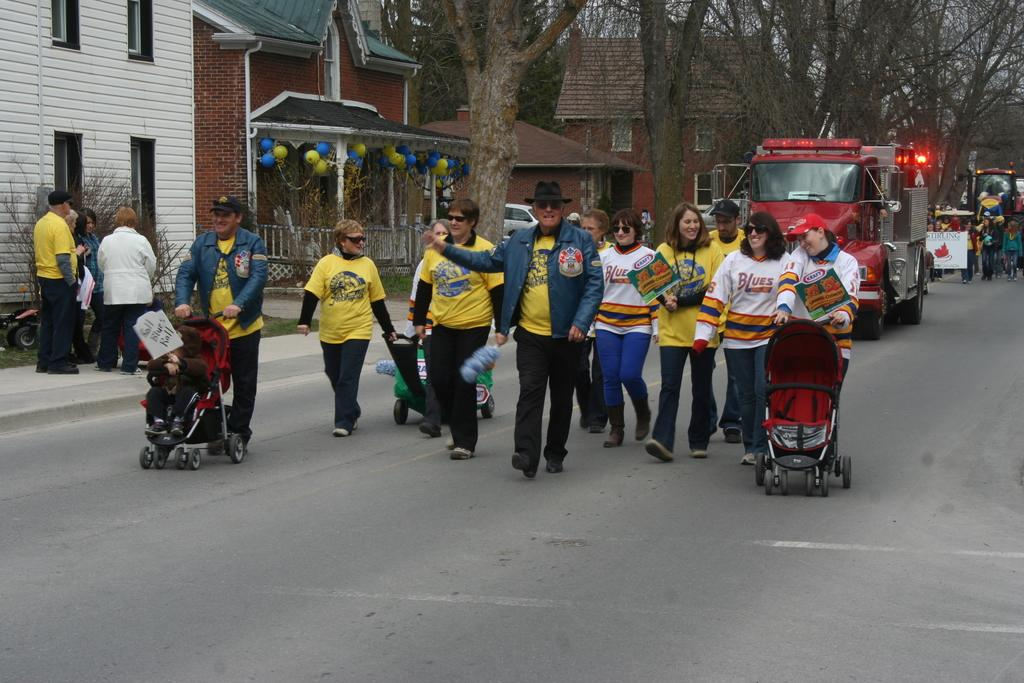What are the people in the image doing? The people in the image are walking. What are the people holding while walking? The people are holding strollers. What else can be seen in the image besides people and strollers? There are vehicles visible in the image. What can be seen at the top of the image? There are trees and buildings at the top of the image. What type of elbow can be seen on the vehicles in the image? There are no elbows present on the vehicles in the image. Vehicles do not have elbows as they are inanimate objects. 